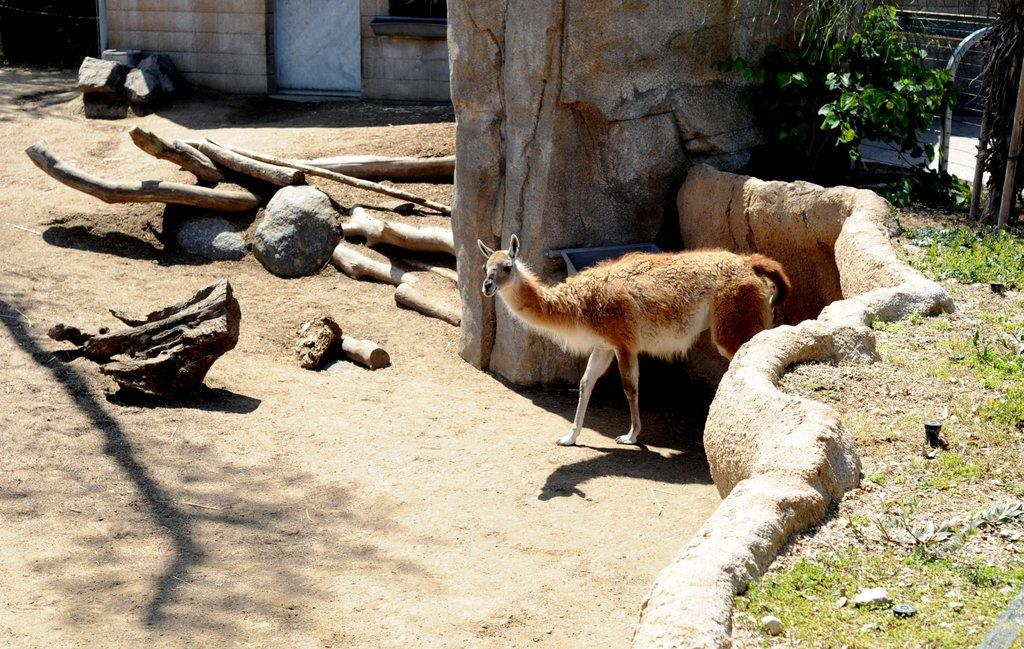What type of animal can be seen in the image? There is an animal standing on the ground in the image. What is the ground covered with in the image? There is grass, wooden branches, and rocks visible on the ground. Are there any other objects on the ground in the image? Yes, there are other objects on the ground. What can be seen in the background of the image? There is a wall visible in the background of the image. What type of toys can be seen scattered around the beggar in the image? There is no beggar or toys present in the image. What type of steel structure can be seen in the image? There is no steel structure present in the image. 